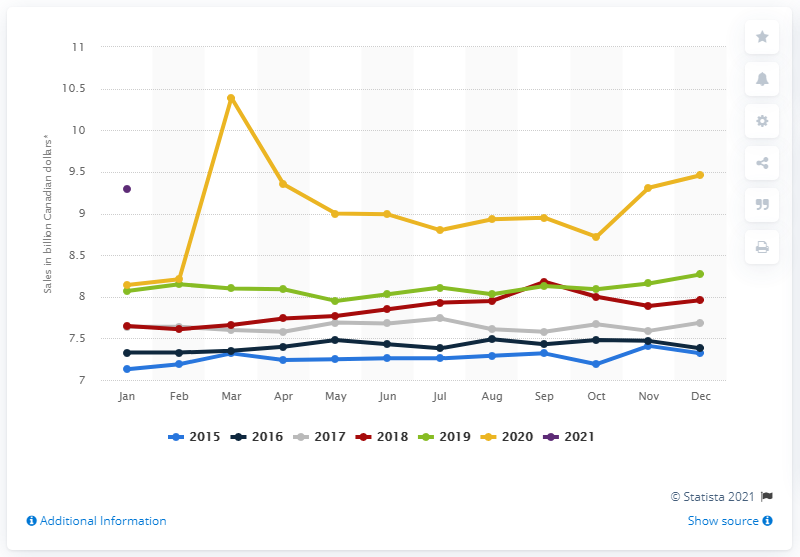What was the monthly sales of grocery stores in Canada in January 2021? According to the visual data presented in the chart, the monthly sales of grocery stores in Canada in January 2021 appears to be approximately 9.3 billion Canadian dollars. The chart shows a comparison of monthly sales over several years, indicating a pattern of consumer spending at grocery stores. 